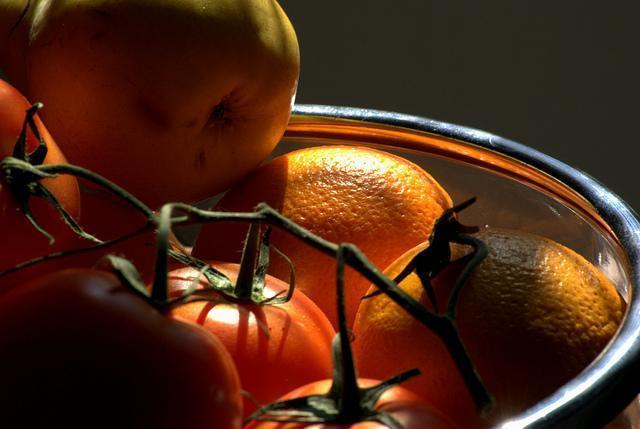How many oranges are there?
Give a very brief answer. 2. 